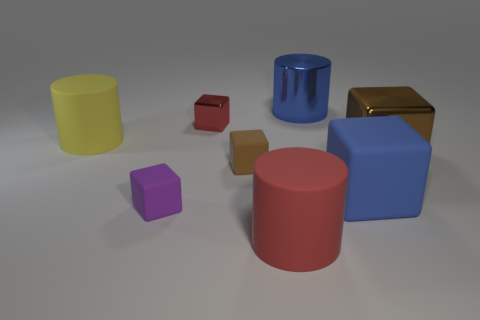There is a block that is the same color as the big shiny cylinder; what is its material?
Your answer should be very brief. Rubber. Is the color of the large block in front of the large brown object the same as the metallic thing that is behind the tiny shiny block?
Your answer should be very brief. Yes. There is a small block behind the big brown cube; how many brown objects are behind it?
Offer a very short reply. 0. Is there a large yellow matte ball?
Your answer should be very brief. No. What number of other objects are the same color as the large metallic block?
Offer a terse response. 1. Are there fewer big red things than tiny cubes?
Keep it short and to the point. Yes. The large object that is on the left side of the brown thing that is to the left of the brown metal thing is what shape?
Offer a terse response. Cylinder. Are there any purple objects to the left of the brown matte block?
Provide a short and direct response. Yes. What color is the other matte cylinder that is the same size as the yellow cylinder?
Provide a short and direct response. Red. How many tiny gray objects have the same material as the tiny brown block?
Offer a terse response. 0. 